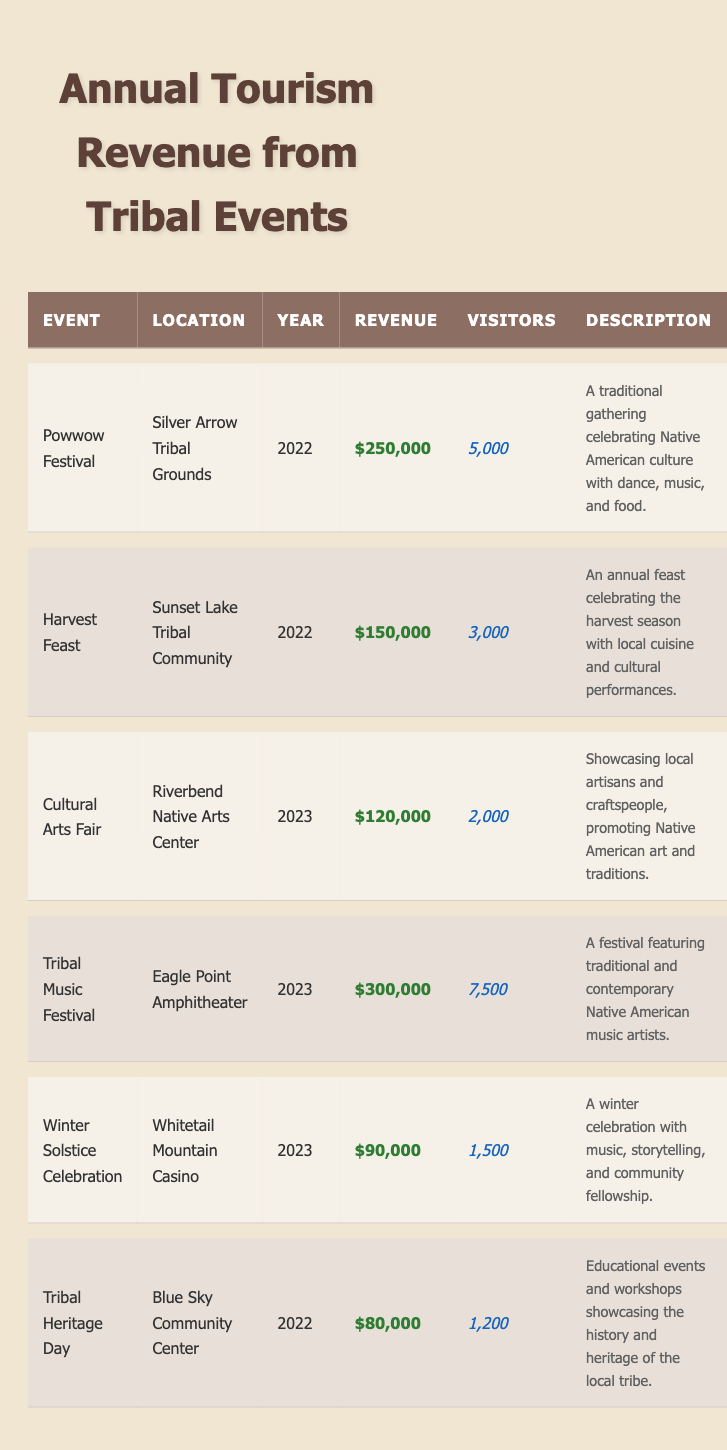What was the revenue generated by the Powwow Festival in 2022? Looking at the table, the Powwow Festival is listed under the year 2022 with a revenue of $250,000.
Answer: $250,000 How many visitors attended the Tribal Music Festival in 2023? The table indicates that the Tribal Music Festival held in 2023 attracted 7,500 visitors.
Answer: 7,500 Which event had the highest revenue in 2023? In 2023, the table shows that the Tribal Music Festival had the highest revenue of $300,000.
Answer: Tribal Music Festival What was the total revenue generated by events held in 2022? To find the total revenue for 2022, we add the revenues of the events: $250,000 (Powwow Festival) + $150,000 (Harvest Feast) + $80,000 (Tribal Heritage Day) = $480,000.
Answer: $480,000 Did the Winter Solstice Celebration generate more revenue than the Cultural Arts Fair? The Winter Solstice Celebration had a revenue of $90,000, while the Cultural Arts Fair had $120,000, so the Winter Solstice Celebration generated less revenue.
Answer: No What is the average number of visitors for all the events listed in 2023? For 2023, the visitor numbers are: 2,000 (Cultural Arts Fair) + 7,500 (Tribal Music Festival) + 1,500 (Winter Solstice Celebration) = 11,000. Dividing by the number of events (3) gives an average of 11,000 / 3 = 3,666.67, which can be rounded to 3,667.
Answer: 3,667 How many more visitors did the Powwow Festival attract compared to the Harvest Feast in 2022? The Powwow Festival had 5,000 visitors and the Harvest Feast had 3,000 visitors. The difference is 5,000 - 3,000 = 2,000 more visitors for the Powwow Festival.
Answer: 2,000 Is it true that the Cultural Arts Fair had more visitors than the Winter Solstice Celebration? The Cultural Arts Fair attracted 2,000 visitors while the Winter Solstice Celebration had 1,500 visitors, thus it is true that the Cultural Arts Fair had more visitors.
Answer: Yes What percentage of the total revenue for 2022 came from the Powwow Festival? For 2022, the total revenue is $480,000. The Powwow Festival's revenue of $250,000 makes up (250,000 / 480,000) * 100 ≈ 52.08%.
Answer: 52.08% Among all the events, what was the overall revenue generated in 2023? The events in 2023 generated the following revenue: $120,000 (Cultural Arts Fair) + $300,000 (Tribal Music Festival) + $90,000 (Winter Solstice Celebration) = $510,000.
Answer: $510,000 